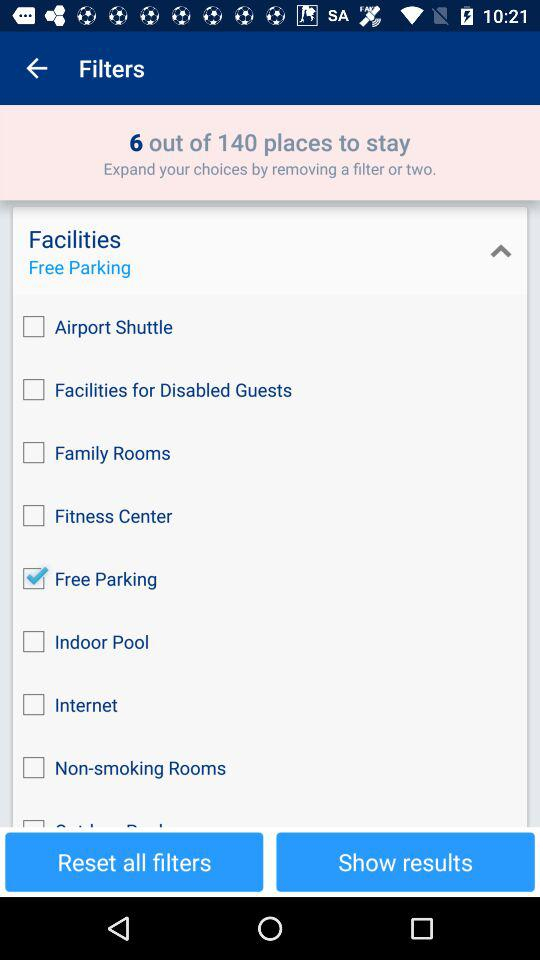How many total places are there to stay? There are a total of 140 places to stay. 